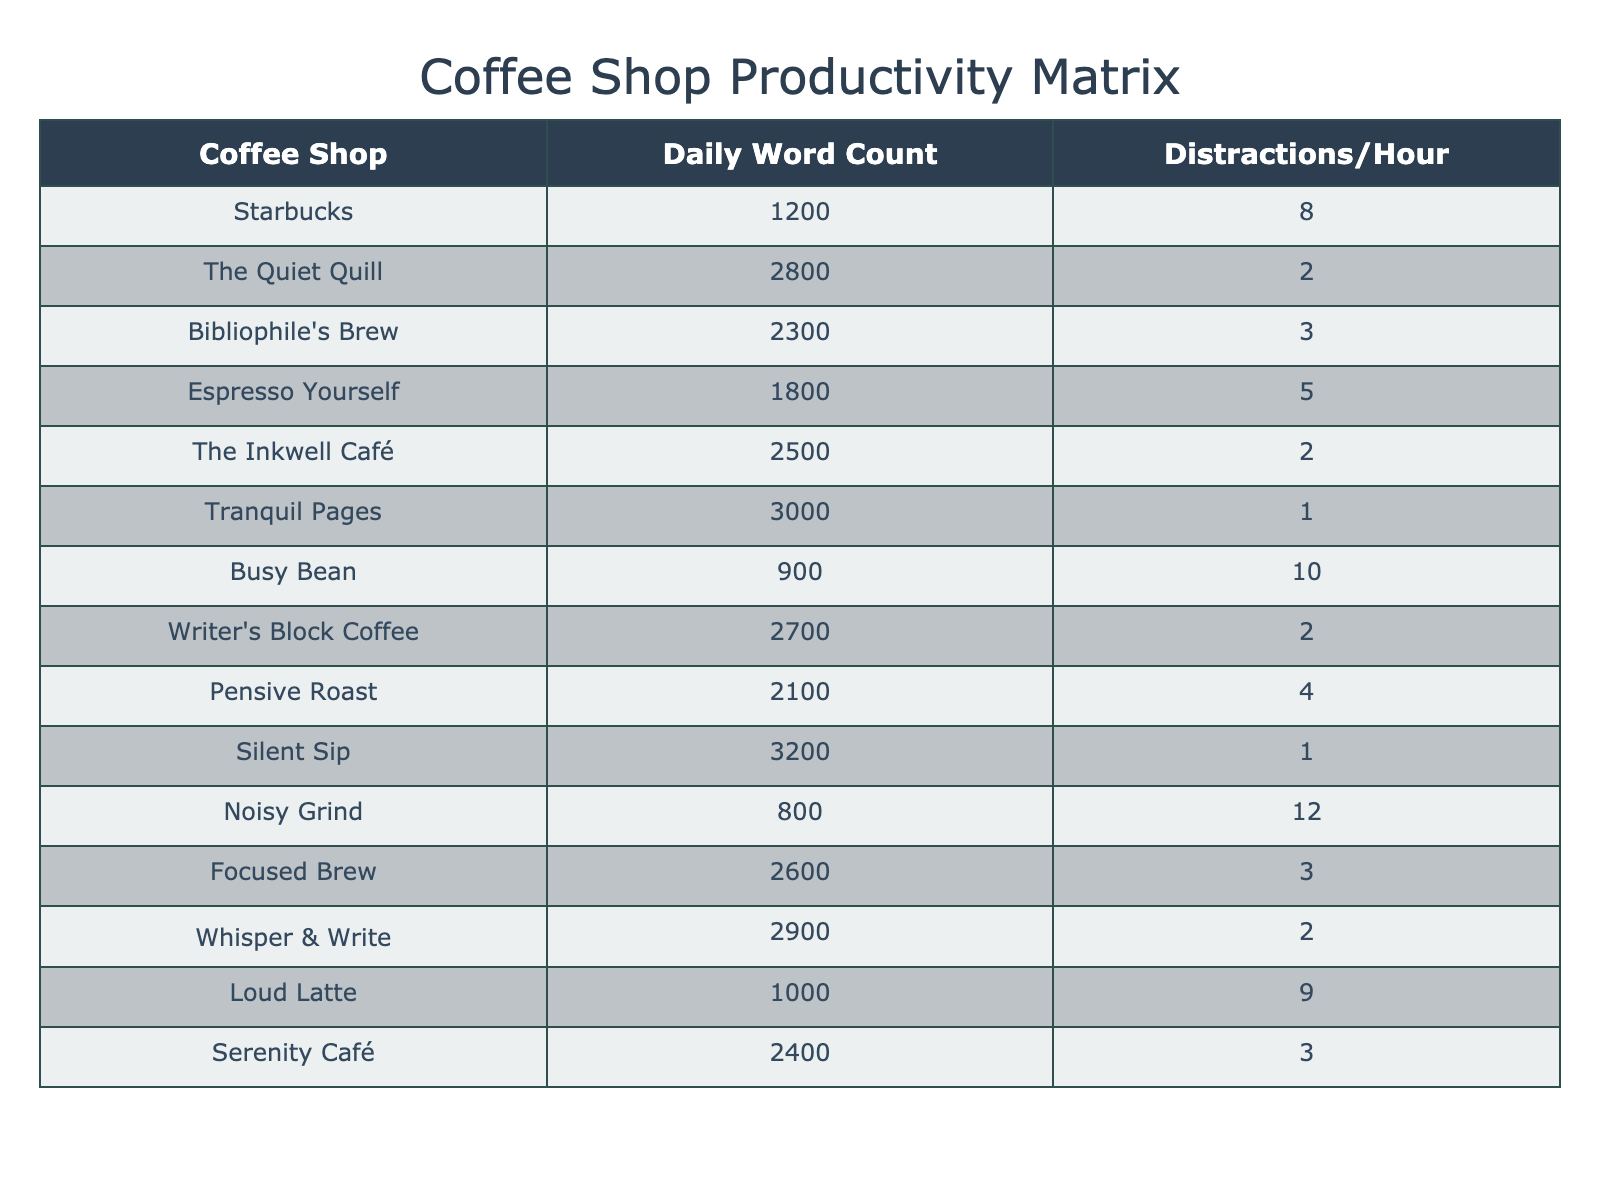What is the daily word count at Tranquil Pages? According to the table, the Daily Word Count for Tranquil Pages is listed directly.
Answer: 3000 Which coffee shop has the highest distraction frequency? By examining the table, Noisy Grind has the highest distraction frequency at 12 distractions per hour.
Answer: Noisy Grind What is the daily word count for the coffee shop with the lowest distraction frequency? Tranquil Pages and Silent Sip both have the lowest distraction frequency of 1 per hour. Their daily word counts are 3000 and 3200, respectively. Thus, Silent Sip has the highest daily word count among these two.
Answer: 3200 How many coffee shops have a daily word count of 2500 or higher? There are seven coffee shops with a daily word count of 2500 or more: The Quiet Quill, The Inkwell Café, Tranquil Pages, Writer's Block Coffee, Whisper & Write, Silent Sip, and Focused Brew.
Answer: 7 What is the average daily word count across all coffee shops listed? To calculate the average, add all the daily word counts (1200 + 2800 + 2300 + 1800 + 2500 + 3000 + 900 + 2700 + 2100 + 3200 + 800 + 2600 + 2900 + 1000 + 2400) which equals 29,400, and divide by the number of shops (15), resulting in an average of 1960.
Answer: 1960 Is there a coffee shop that allows for more than 2500 words and has a distraction frequency less than or equal to 3? Yes, both The Quiet Quill and The Inkwell Café have daily word counts over 2500 with distraction frequencies of 2 each.
Answer: Yes What is the difference in word count between the coffee shop with the highest and the lowest daily word count? The highest daily word count is Silent Sip at 3200, and the lowest is Noisy Grind at 800. The difference is 3200 - 800 = 2400.
Answer: 2400 How many coffee shops have a distraction frequency of 5 or fewer? By counting from the table, there are 8 coffee shops (Tranquil Pages, The Quiet Quill, The Inkwell Café, Writer's Block Coffee, Pensive Roast, Silent Sip, Whisper & Write, Focused Brew) that have 5 or fewer distractions per hour.
Answer: 8 What is the total daily word count for coffee shops with distraction frequencies of 5 or more? The shops with high distractions (Busy Bean, Noisy Grind, and Loud Latte) have daily word counts of 900, 800, and 1000 respectively. Their total is 900 + 800 + 1000 = 2700.
Answer: 2700 Which coffee shop has a better word count to distraction frequency ratio: Espresso Yourself or Pensive Roast? Espresso Yourself has a ratio of 1800/5 = 360, while Pensive Roast has 2100/4 = 525, indicating Pensive Roast has a better ratio.
Answer: Pensive Roast 